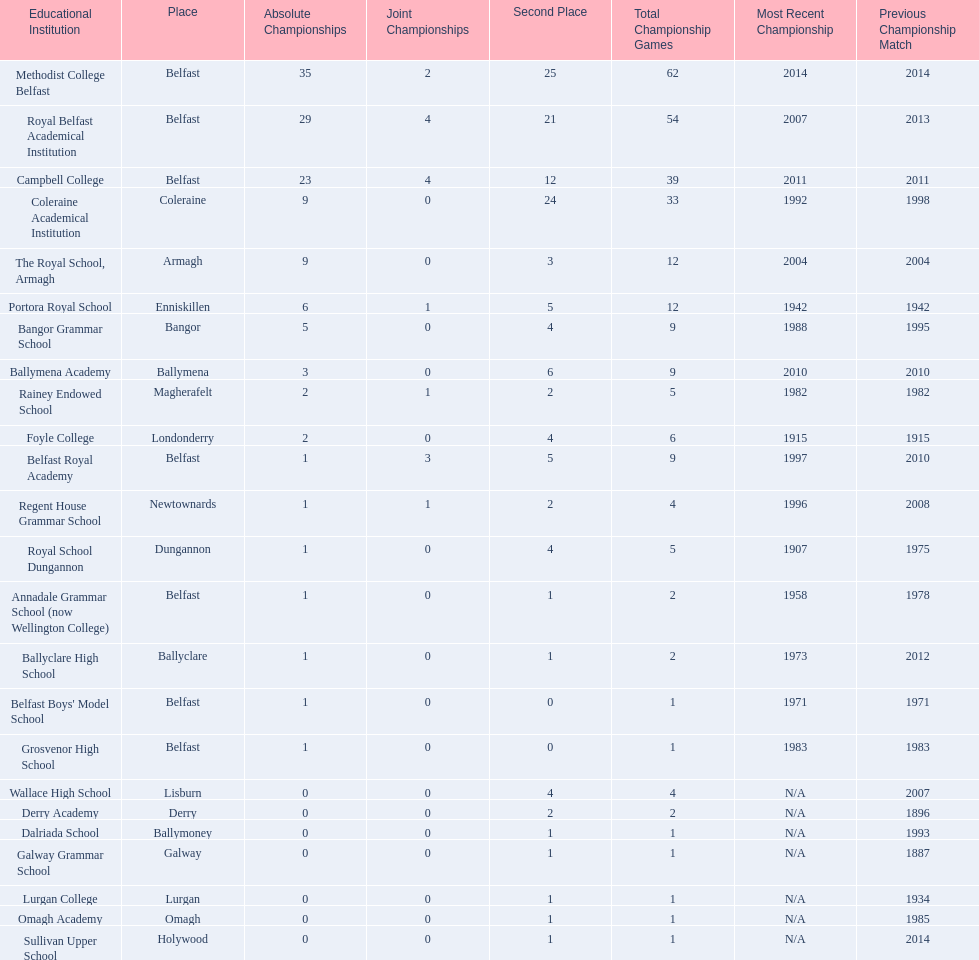How many schools are there? Methodist College Belfast, Royal Belfast Academical Institution, Campbell College, Coleraine Academical Institution, The Royal School, Armagh, Portora Royal School, Bangor Grammar School, Ballymena Academy, Rainey Endowed School, Foyle College, Belfast Royal Academy, Regent House Grammar School, Royal School Dungannon, Annadale Grammar School (now Wellington College), Ballyclare High School, Belfast Boys' Model School, Grosvenor High School, Wallace High School, Derry Academy, Dalriada School, Galway Grammar School, Lurgan College, Omagh Academy, Sullivan Upper School. How many outright titles does the coleraine academical institution have? 9. What other school has the same number of outright titles? The Royal School, Armagh. 